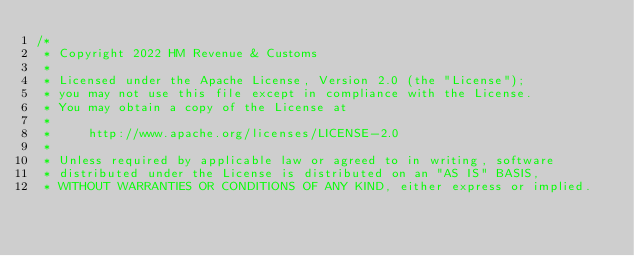Convert code to text. <code><loc_0><loc_0><loc_500><loc_500><_Scala_>/*
 * Copyright 2022 HM Revenue & Customs
 *
 * Licensed under the Apache License, Version 2.0 (the "License");
 * you may not use this file except in compliance with the License.
 * You may obtain a copy of the License at
 *
 *     http://www.apache.org/licenses/LICENSE-2.0
 *
 * Unless required by applicable law or agreed to in writing, software
 * distributed under the License is distributed on an "AS IS" BASIS,
 * WITHOUT WARRANTIES OR CONDITIONS OF ANY KIND, either express or implied.</code> 